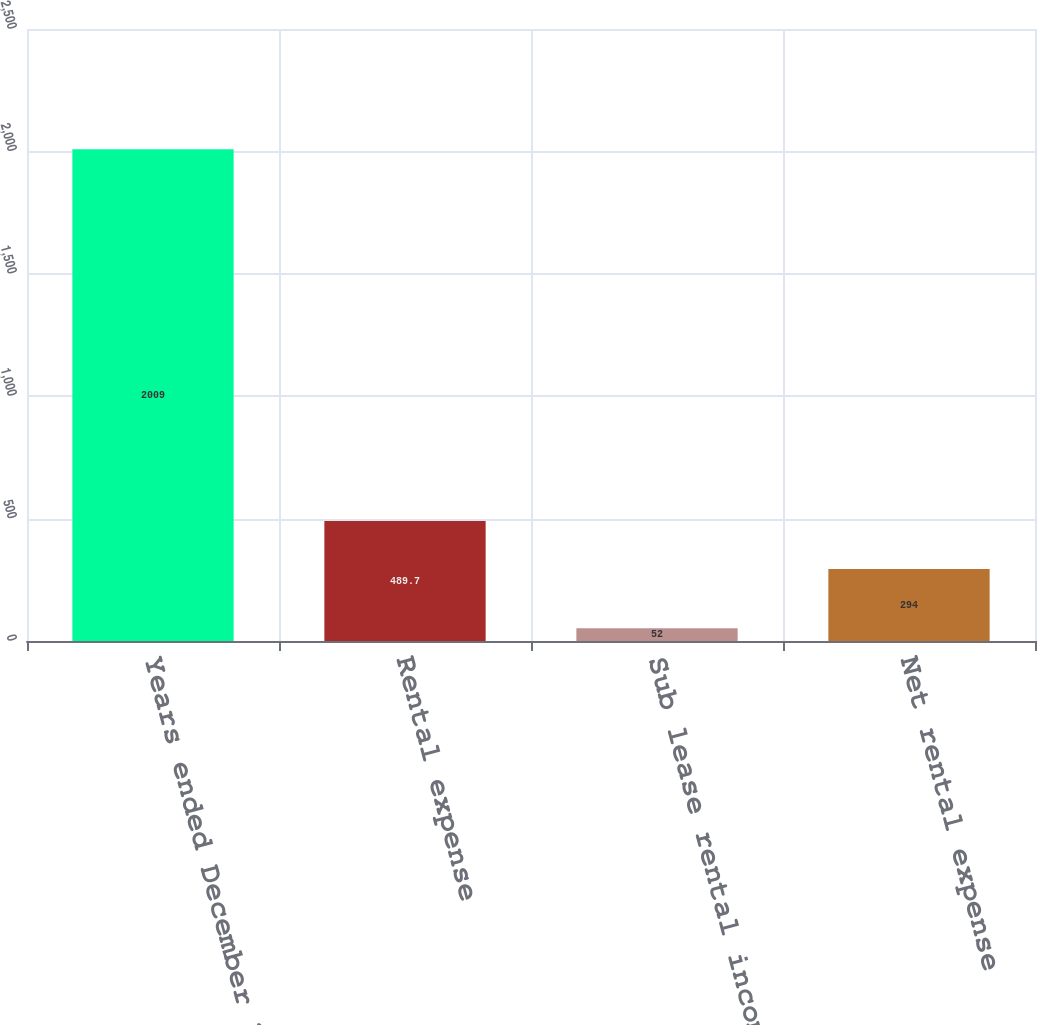Convert chart. <chart><loc_0><loc_0><loc_500><loc_500><bar_chart><fcel>Years ended December 31<fcel>Rental expense<fcel>Sub lease rental income<fcel>Net rental expense<nl><fcel>2009<fcel>489.7<fcel>52<fcel>294<nl></chart> 